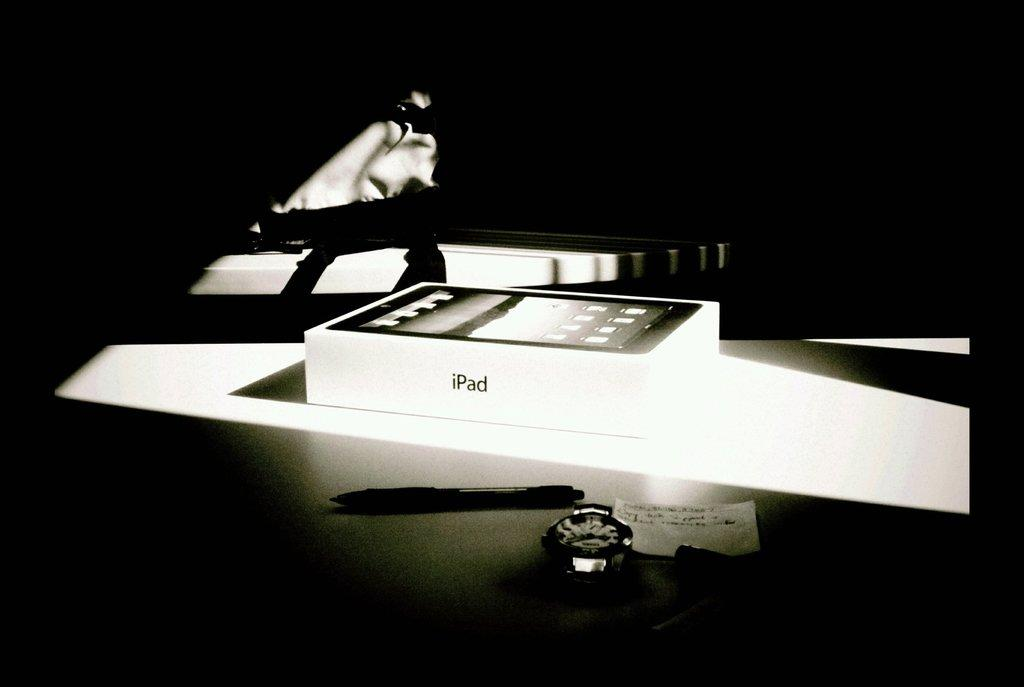<image>
Summarize the visual content of the image. A white box with the word iPad on its side. 